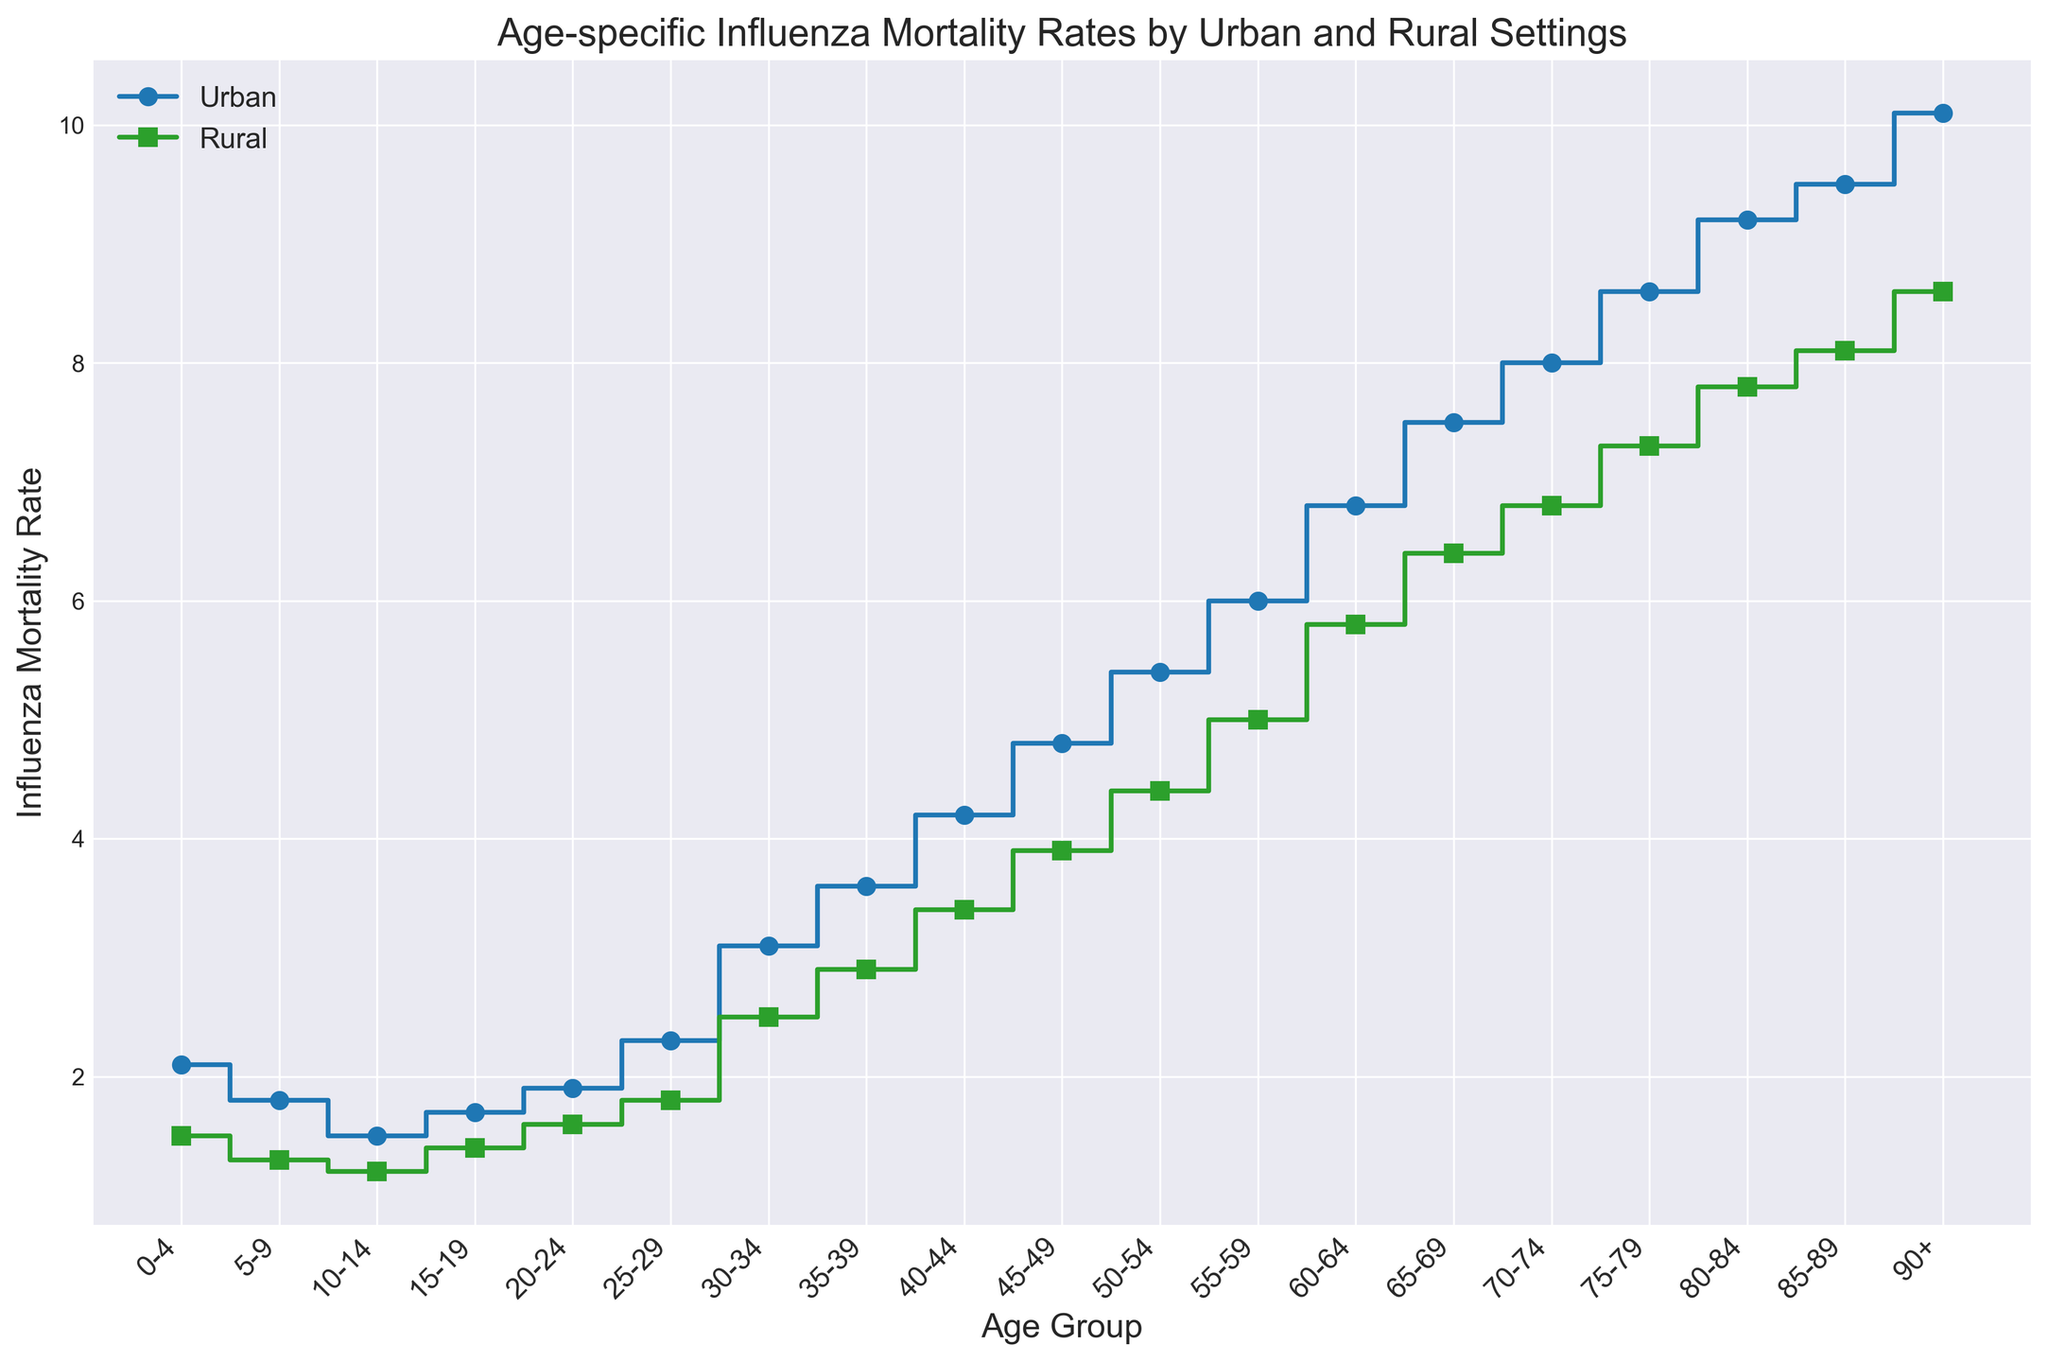What's the difference in mortality rates between urban and rural settings for the age group 45-49? The figure shows mortality rates on the y-axis for each age group on the x-axis. For the age group 45-49, the urban mortality rate is 4.8, and the rural mortality rate is 3.9. Subtract the rural rate from the urban rate (4.8 - 3.9).
Answer: 0.9 Which age group has the highest mortality rate in both urban and rural settings? Look at the heights of the steps (lines) for both urban and rural settings. The tallest steps in both cases are for the age group 90+, where the urban mortality rate is 10.1 and the rural mortality rate is 8.6.
Answer: 90+ Is the mortality rate for the 25-29 age group higher in urban or rural settings? Compare the mortality rates for the 25-29 age group by looking at the height of the steps. The urban setting has a mortality rate of 2.3 while the rural setting has 1.8. The urban setting has a higher rate.
Answer: Urban What's the average mortality rate for urban settings for the age groups 0-4 and 5-9? Add the mortality rates for the age groups 0-4 and 5-9 in urban settings (2.1 + 1.8) and divide by 2. The result of (2.1 + 1.8)/2 is 1.95.
Answer: 1.95 Which setting, urban or rural, shows a steeper increase in mortality rates as age increases? Observe the overall slope of the lines. The urban line has a steeper slope as it starts at a low value and rises to a higher peak compared to the rural line.
Answer: Urban What is the mortality rate for the 50-54 age group in rural settings? Locate the age group 50-54 on the x-axis and check the corresponding step height for rural settings. The mortality rate for this age group in rural settings is shown as 4.4.
Answer: 4.4 By how much does the urban mortality rate increase from the 60-64 age group to the 65-69 age group? Identify the mortality rates for the 60-64 and 65-69 age groups in urban settings, which are 6.8 and 7.5 respectively. Subtract the 60-64 rate from the 65-69 rate (7.5 - 6.8).
Answer: 0.7 What age group has the smallest difference in mortality rates between urban and rural settings? Compare differences in mortality rates between urban and rural settings across all age groups. The smallest difference is for the age group 85-89 where the urban rate is 9.5 and the rural rate is 8.1, a difference of 1.4.
Answer: 85-89 Which age group sees a mortality rate greater than 8 only in the urban setting? Check the mortality rates across the age groups where the urban rate exceeds 8. Only the age group 80-84 meets this criterion with a rate of 9.2, while the rural rate is below 8.
Answer: 80-84 